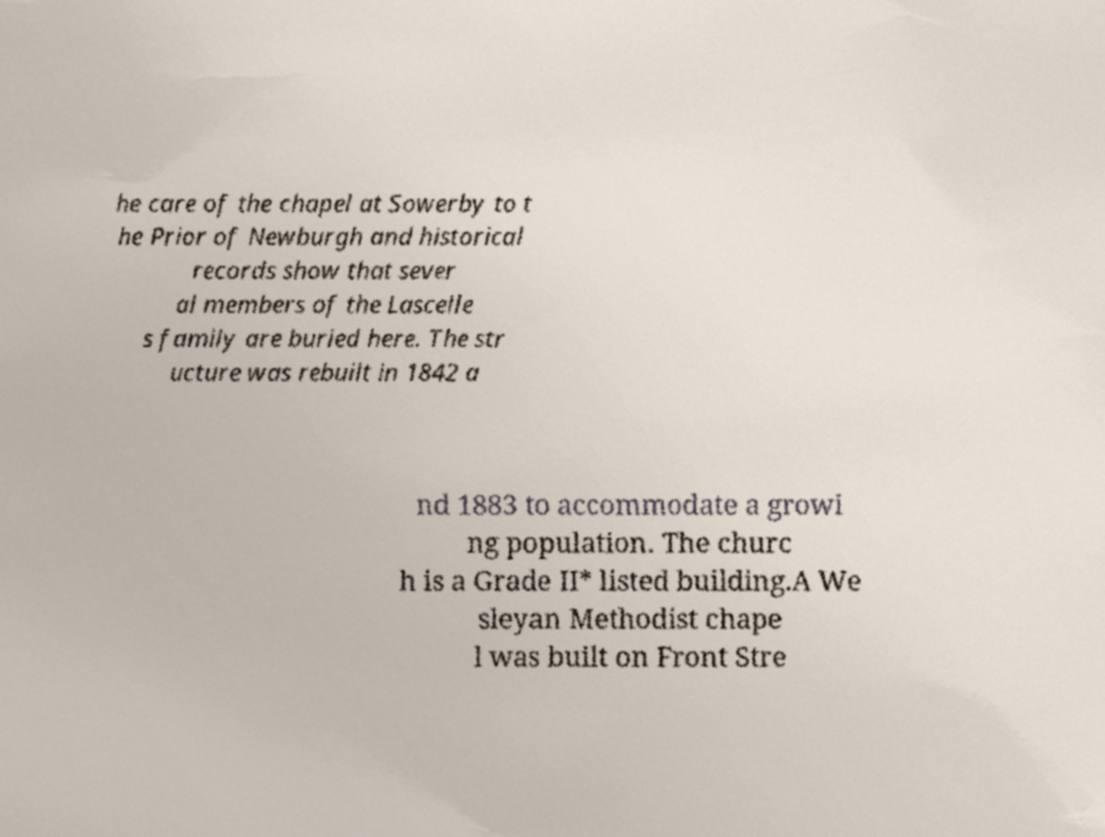I need the written content from this picture converted into text. Can you do that? he care of the chapel at Sowerby to t he Prior of Newburgh and historical records show that sever al members of the Lascelle s family are buried here. The str ucture was rebuilt in 1842 a nd 1883 to accommodate a growi ng population. The churc h is a Grade II* listed building.A We sleyan Methodist chape l was built on Front Stre 